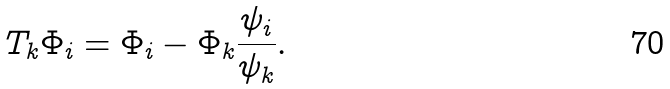<formula> <loc_0><loc_0><loc_500><loc_500>T _ { k } \Phi _ { i } = \Phi _ { i } - \Phi _ { k } \frac { \psi _ { i } } { \psi _ { k } } .</formula> 